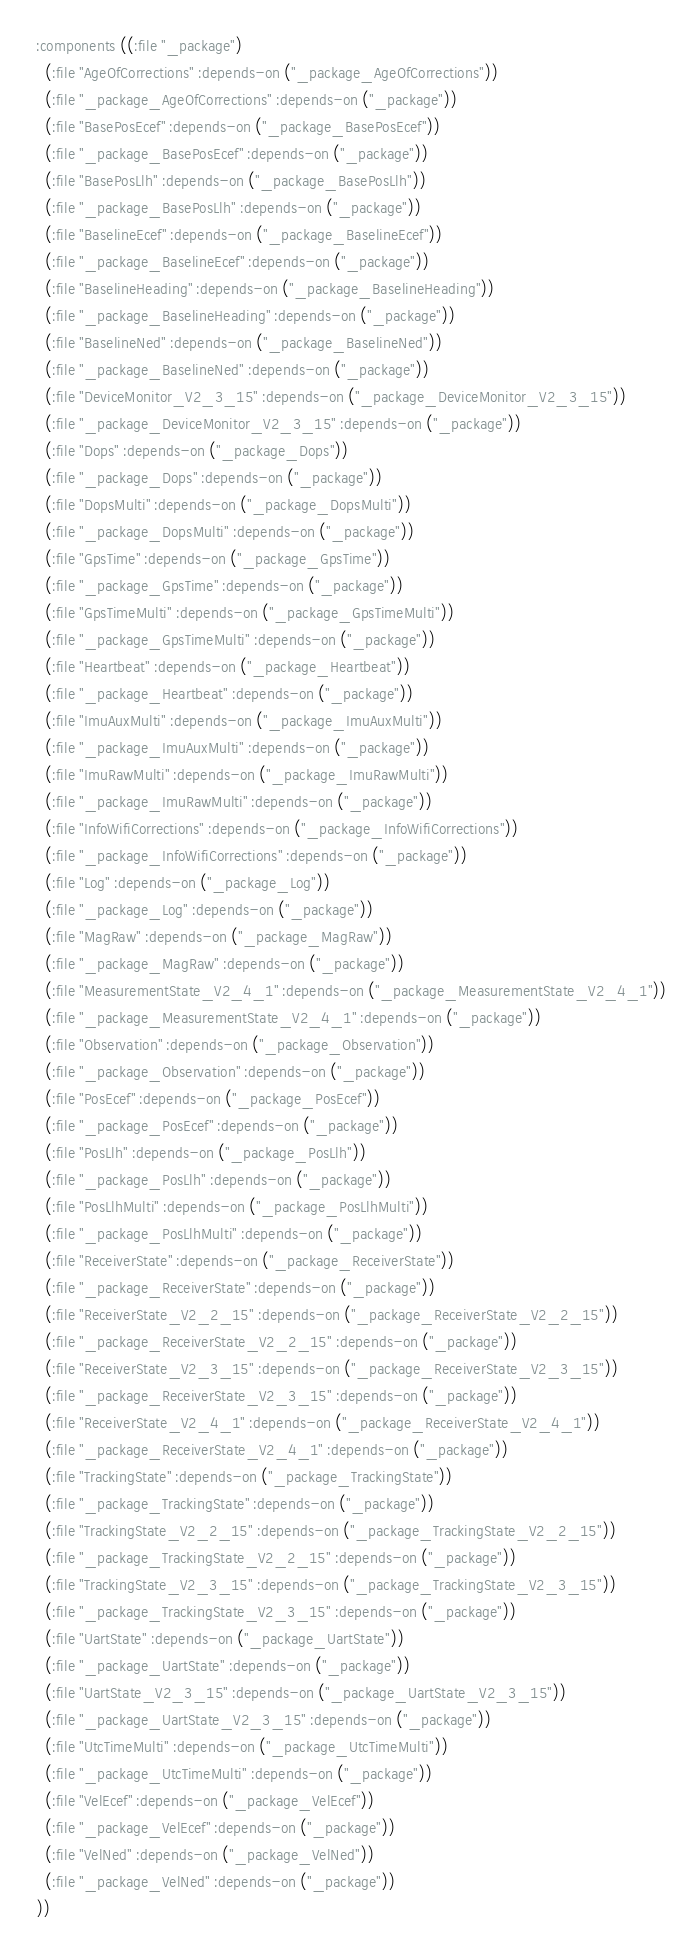<code> <loc_0><loc_0><loc_500><loc_500><_Lisp_>  :components ((:file "_package")
    (:file "AgeOfCorrections" :depends-on ("_package_AgeOfCorrections"))
    (:file "_package_AgeOfCorrections" :depends-on ("_package"))
    (:file "BasePosEcef" :depends-on ("_package_BasePosEcef"))
    (:file "_package_BasePosEcef" :depends-on ("_package"))
    (:file "BasePosLlh" :depends-on ("_package_BasePosLlh"))
    (:file "_package_BasePosLlh" :depends-on ("_package"))
    (:file "BaselineEcef" :depends-on ("_package_BaselineEcef"))
    (:file "_package_BaselineEcef" :depends-on ("_package"))
    (:file "BaselineHeading" :depends-on ("_package_BaselineHeading"))
    (:file "_package_BaselineHeading" :depends-on ("_package"))
    (:file "BaselineNed" :depends-on ("_package_BaselineNed"))
    (:file "_package_BaselineNed" :depends-on ("_package"))
    (:file "DeviceMonitor_V2_3_15" :depends-on ("_package_DeviceMonitor_V2_3_15"))
    (:file "_package_DeviceMonitor_V2_3_15" :depends-on ("_package"))
    (:file "Dops" :depends-on ("_package_Dops"))
    (:file "_package_Dops" :depends-on ("_package"))
    (:file "DopsMulti" :depends-on ("_package_DopsMulti"))
    (:file "_package_DopsMulti" :depends-on ("_package"))
    (:file "GpsTime" :depends-on ("_package_GpsTime"))
    (:file "_package_GpsTime" :depends-on ("_package"))
    (:file "GpsTimeMulti" :depends-on ("_package_GpsTimeMulti"))
    (:file "_package_GpsTimeMulti" :depends-on ("_package"))
    (:file "Heartbeat" :depends-on ("_package_Heartbeat"))
    (:file "_package_Heartbeat" :depends-on ("_package"))
    (:file "ImuAuxMulti" :depends-on ("_package_ImuAuxMulti"))
    (:file "_package_ImuAuxMulti" :depends-on ("_package"))
    (:file "ImuRawMulti" :depends-on ("_package_ImuRawMulti"))
    (:file "_package_ImuRawMulti" :depends-on ("_package"))
    (:file "InfoWifiCorrections" :depends-on ("_package_InfoWifiCorrections"))
    (:file "_package_InfoWifiCorrections" :depends-on ("_package"))
    (:file "Log" :depends-on ("_package_Log"))
    (:file "_package_Log" :depends-on ("_package"))
    (:file "MagRaw" :depends-on ("_package_MagRaw"))
    (:file "_package_MagRaw" :depends-on ("_package"))
    (:file "MeasurementState_V2_4_1" :depends-on ("_package_MeasurementState_V2_4_1"))
    (:file "_package_MeasurementState_V2_4_1" :depends-on ("_package"))
    (:file "Observation" :depends-on ("_package_Observation"))
    (:file "_package_Observation" :depends-on ("_package"))
    (:file "PosEcef" :depends-on ("_package_PosEcef"))
    (:file "_package_PosEcef" :depends-on ("_package"))
    (:file "PosLlh" :depends-on ("_package_PosLlh"))
    (:file "_package_PosLlh" :depends-on ("_package"))
    (:file "PosLlhMulti" :depends-on ("_package_PosLlhMulti"))
    (:file "_package_PosLlhMulti" :depends-on ("_package"))
    (:file "ReceiverState" :depends-on ("_package_ReceiverState"))
    (:file "_package_ReceiverState" :depends-on ("_package"))
    (:file "ReceiverState_V2_2_15" :depends-on ("_package_ReceiverState_V2_2_15"))
    (:file "_package_ReceiverState_V2_2_15" :depends-on ("_package"))
    (:file "ReceiverState_V2_3_15" :depends-on ("_package_ReceiverState_V2_3_15"))
    (:file "_package_ReceiverState_V2_3_15" :depends-on ("_package"))
    (:file "ReceiverState_V2_4_1" :depends-on ("_package_ReceiverState_V2_4_1"))
    (:file "_package_ReceiverState_V2_4_1" :depends-on ("_package"))
    (:file "TrackingState" :depends-on ("_package_TrackingState"))
    (:file "_package_TrackingState" :depends-on ("_package"))
    (:file "TrackingState_V2_2_15" :depends-on ("_package_TrackingState_V2_2_15"))
    (:file "_package_TrackingState_V2_2_15" :depends-on ("_package"))
    (:file "TrackingState_V2_3_15" :depends-on ("_package_TrackingState_V2_3_15"))
    (:file "_package_TrackingState_V2_3_15" :depends-on ("_package"))
    (:file "UartState" :depends-on ("_package_UartState"))
    (:file "_package_UartState" :depends-on ("_package"))
    (:file "UartState_V2_3_15" :depends-on ("_package_UartState_V2_3_15"))
    (:file "_package_UartState_V2_3_15" :depends-on ("_package"))
    (:file "UtcTimeMulti" :depends-on ("_package_UtcTimeMulti"))
    (:file "_package_UtcTimeMulti" :depends-on ("_package"))
    (:file "VelEcef" :depends-on ("_package_VelEcef"))
    (:file "_package_VelEcef" :depends-on ("_package"))
    (:file "VelNed" :depends-on ("_package_VelNed"))
    (:file "_package_VelNed" :depends-on ("_package"))
  ))</code> 